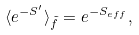Convert formula to latex. <formula><loc_0><loc_0><loc_500><loc_500>\langle e ^ { - S ^ { \prime } } \rangle _ { \tilde { f } } = e ^ { - S _ { e f f } } ,</formula> 